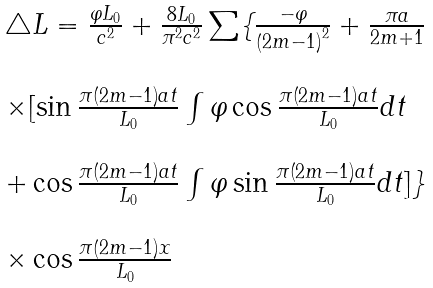Convert formula to latex. <formula><loc_0><loc_0><loc_500><loc_500>\begin{array} { l l l l } \triangle L = \frac { \varphi L _ { 0 } } { c ^ { 2 } } + \frac { 8 L _ { 0 } } { \pi ^ { 2 } c ^ { 2 } } \sum \{ \frac { - \varphi } { \left ( 2 m - 1 \right ) ^ { 2 } } + \frac { \pi a } { 2 m + 1 } \\ \\ \times [ \sin \frac { \pi \left ( 2 m - 1 \right ) a t } { L _ { 0 } } \int \varphi \cos \frac { \pi \left ( 2 m - 1 \right ) a t } { L _ { 0 } } d t \\ \\ + \cos \frac { \pi \left ( 2 m - 1 \right ) a t } { L _ { 0 } } \int \varphi \sin \frac { \pi \left ( 2 m - 1 \right ) a t } { L _ { 0 } } d t ] \} \\ \\ \times \cos \frac { \pi \left ( 2 m - 1 \right ) x } { L _ { 0 } } \end{array}</formula> 